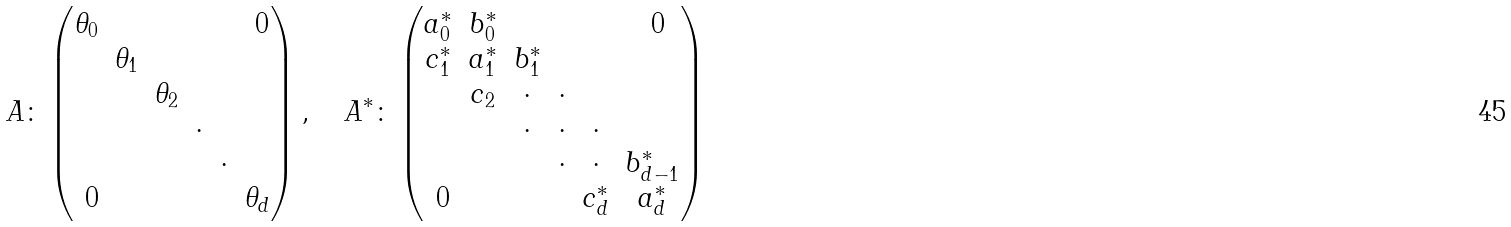Convert formula to latex. <formula><loc_0><loc_0><loc_500><loc_500>A \colon \begin{pmatrix} \theta _ { 0 } & & & & & \text { 0} \\ & \theta _ { 1 } \\ & & \theta _ { 2 } \\ & & & \cdot \\ & & & & \cdot \\ \text { 0} & & & & & \theta _ { d } \end{pmatrix} , \quad A ^ { * } \colon \begin{pmatrix} a ^ { * } _ { 0 } & b ^ { * } _ { 0 } & & & & \text { 0} \\ c ^ { * } _ { 1 } & a ^ { * } _ { 1 } & b ^ { * } _ { 1 } \\ & c _ { 2 } & \cdot & \cdot \\ & & \cdot & \cdot & \cdot \\ & & & \cdot & \cdot & b ^ { * } _ { d - 1 } \\ \text { 0} & & & & c ^ { * } _ { d } & a ^ { * } _ { d } \end{pmatrix}</formula> 